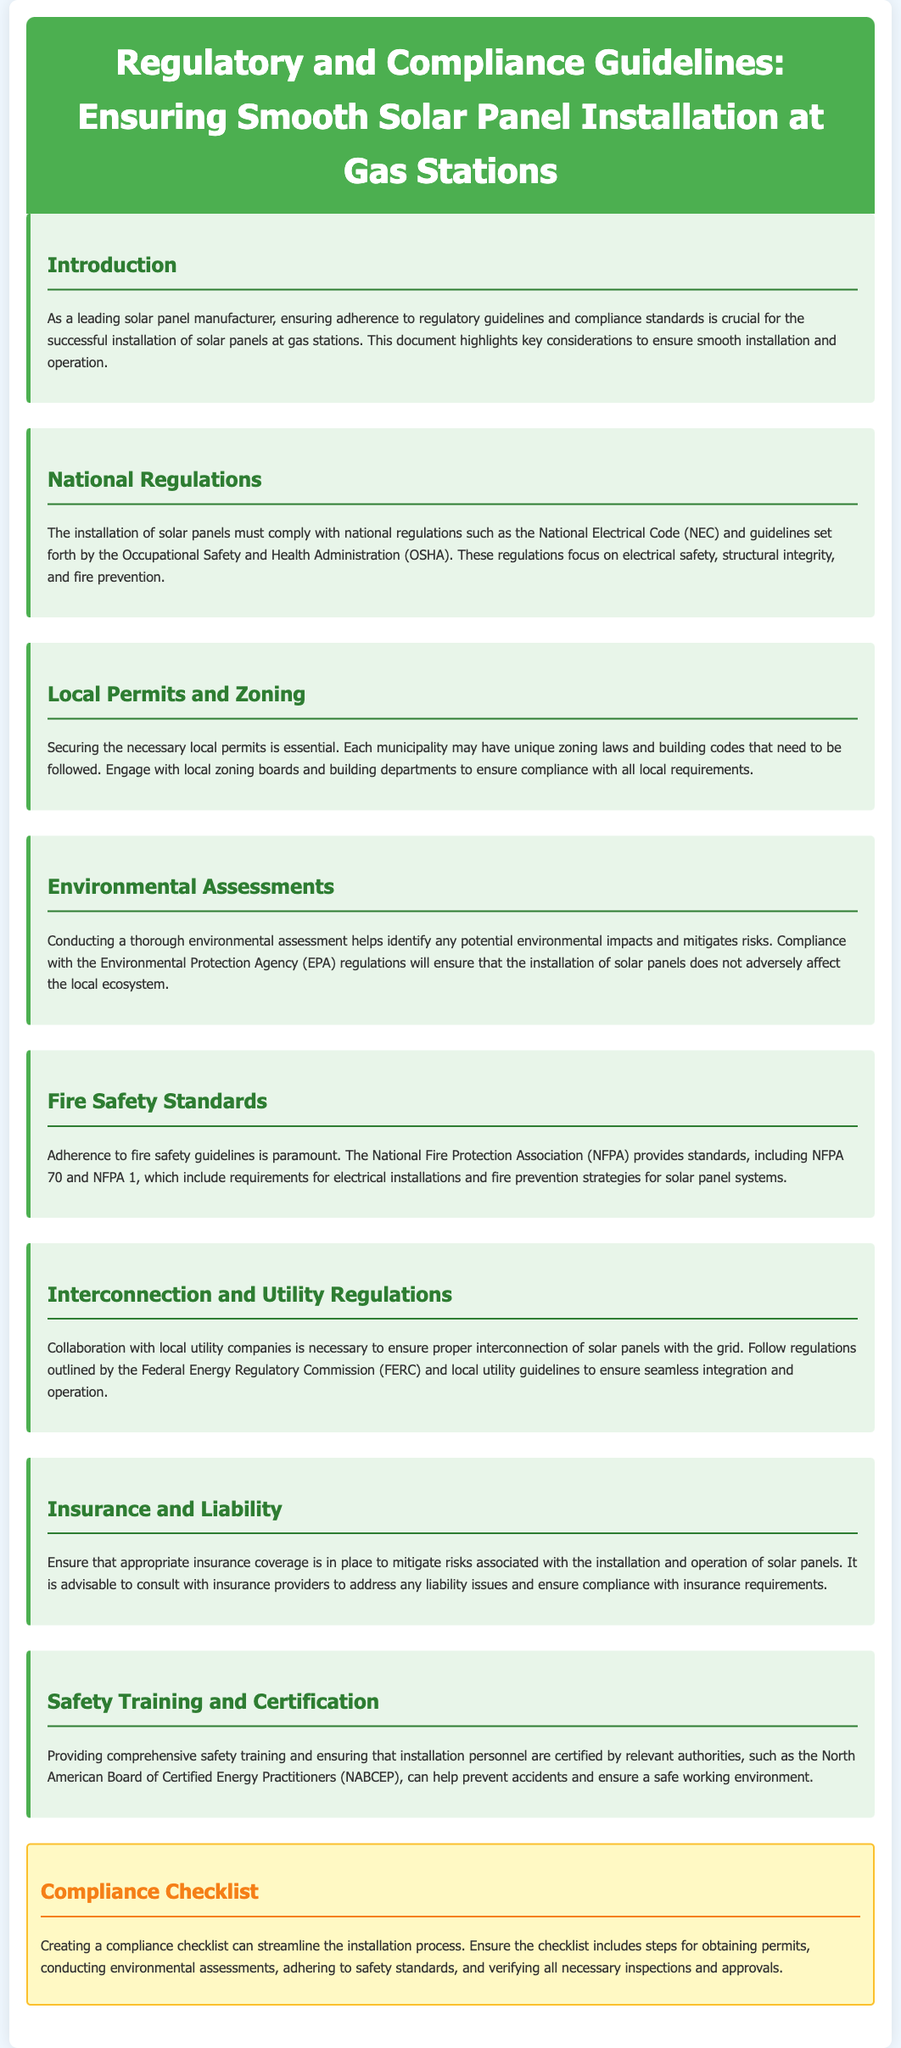What are the national regulations to comply with? The document specifies compliance with the National Electrical Code (NEC) and guidelines from the Occupational Safety and Health Administration (OSHA).
Answer: National Electrical Code and Occupational Safety and Health Administration What is necessary to secure for installation? The document mentions that securing local permits is essential for installation, which varies by municipality.
Answer: Local permits Which agency's regulations must be followed for environmental assessments? The document states that compliance with the Environmental Protection Agency (EPA) regulations is necessary for environmental assessments.
Answer: Environmental Protection Agency What should be included in the compliance checklist? The compliance checklist should include steps for obtaining permits, conducting environmental assessments, and adhering to safety standards.
Answer: Permits, environmental assessments, safety standards Who provides certification for installation personnel? According to the document, certification is provided by the North American Board of Certified Energy Practitioners (NABCEP).
Answer: North American Board of Certified Energy Practitioners What ensures the integration of solar panels with the grid? Collaboration with local utility companies is necessary to ensure proper interconnection of solar panels with the grid.
Answer: Collaboration with local utility companies What fire safety standards must be followed? The document states that adherence to the National Fire Protection Association (NFPA) standards is crucial, specifically NFPA 70 and NFPA 1.
Answer: National Fire Protection Association What is important for mitigating risks during installation? The document highlights the importance of having appropriate insurance coverage in place to mitigate risks associated with installation and operation.
Answer: Appropriate insurance coverage 